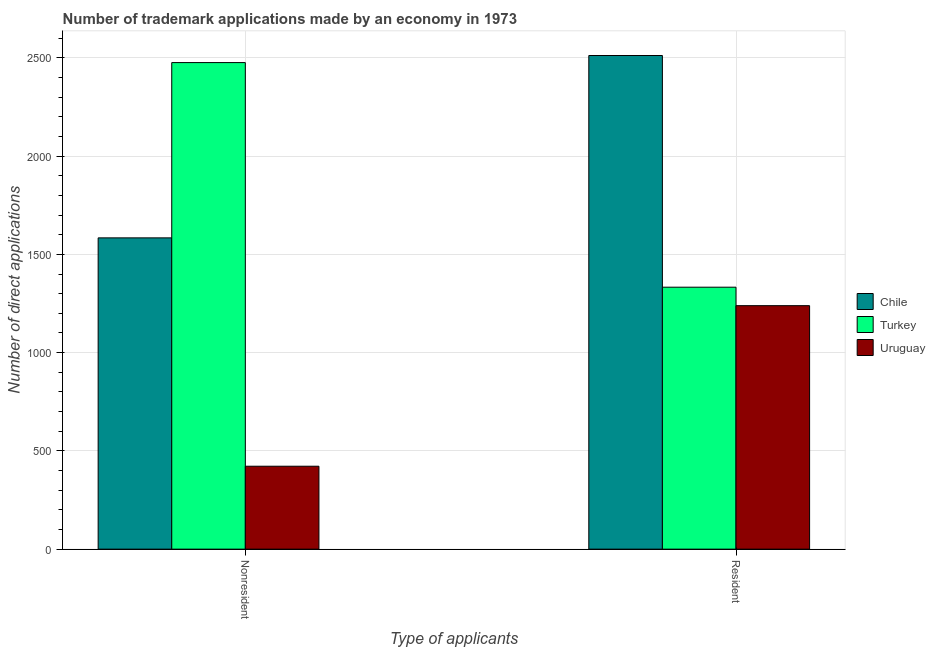How many different coloured bars are there?
Provide a short and direct response. 3. How many groups of bars are there?
Offer a very short reply. 2. Are the number of bars on each tick of the X-axis equal?
Provide a succinct answer. Yes. What is the label of the 2nd group of bars from the left?
Offer a very short reply. Resident. What is the number of trademark applications made by residents in Turkey?
Make the answer very short. 1333. Across all countries, what is the maximum number of trademark applications made by residents?
Offer a very short reply. 2512. Across all countries, what is the minimum number of trademark applications made by residents?
Give a very brief answer. 1239. In which country was the number of trademark applications made by residents maximum?
Give a very brief answer. Chile. In which country was the number of trademark applications made by residents minimum?
Your answer should be compact. Uruguay. What is the total number of trademark applications made by residents in the graph?
Make the answer very short. 5084. What is the difference between the number of trademark applications made by residents in Chile and that in Uruguay?
Your answer should be very brief. 1273. What is the difference between the number of trademark applications made by residents in Chile and the number of trademark applications made by non residents in Uruguay?
Provide a short and direct response. 2090. What is the average number of trademark applications made by residents per country?
Your response must be concise. 1694.67. What is the difference between the number of trademark applications made by non residents and number of trademark applications made by residents in Uruguay?
Your answer should be very brief. -817. In how many countries, is the number of trademark applications made by non residents greater than 900 ?
Your answer should be compact. 2. What is the ratio of the number of trademark applications made by residents in Uruguay to that in Turkey?
Make the answer very short. 0.93. In how many countries, is the number of trademark applications made by residents greater than the average number of trademark applications made by residents taken over all countries?
Provide a short and direct response. 1. What does the 3rd bar from the left in Nonresident represents?
Make the answer very short. Uruguay. What does the 3rd bar from the right in Nonresident represents?
Ensure brevity in your answer.  Chile. Are all the bars in the graph horizontal?
Offer a very short reply. No. How many countries are there in the graph?
Your answer should be compact. 3. What is the difference between two consecutive major ticks on the Y-axis?
Keep it short and to the point. 500. Where does the legend appear in the graph?
Your answer should be compact. Center right. How many legend labels are there?
Make the answer very short. 3. How are the legend labels stacked?
Ensure brevity in your answer.  Vertical. What is the title of the graph?
Give a very brief answer. Number of trademark applications made by an economy in 1973. What is the label or title of the X-axis?
Keep it short and to the point. Type of applicants. What is the label or title of the Y-axis?
Offer a terse response. Number of direct applications. What is the Number of direct applications in Chile in Nonresident?
Provide a succinct answer. 1584. What is the Number of direct applications in Turkey in Nonresident?
Your answer should be compact. 2476. What is the Number of direct applications in Uruguay in Nonresident?
Give a very brief answer. 422. What is the Number of direct applications in Chile in Resident?
Provide a short and direct response. 2512. What is the Number of direct applications of Turkey in Resident?
Provide a short and direct response. 1333. What is the Number of direct applications in Uruguay in Resident?
Offer a very short reply. 1239. Across all Type of applicants, what is the maximum Number of direct applications in Chile?
Your answer should be very brief. 2512. Across all Type of applicants, what is the maximum Number of direct applications of Turkey?
Give a very brief answer. 2476. Across all Type of applicants, what is the maximum Number of direct applications in Uruguay?
Offer a very short reply. 1239. Across all Type of applicants, what is the minimum Number of direct applications of Chile?
Give a very brief answer. 1584. Across all Type of applicants, what is the minimum Number of direct applications in Turkey?
Give a very brief answer. 1333. Across all Type of applicants, what is the minimum Number of direct applications of Uruguay?
Provide a short and direct response. 422. What is the total Number of direct applications of Chile in the graph?
Your response must be concise. 4096. What is the total Number of direct applications of Turkey in the graph?
Offer a terse response. 3809. What is the total Number of direct applications in Uruguay in the graph?
Make the answer very short. 1661. What is the difference between the Number of direct applications in Chile in Nonresident and that in Resident?
Provide a short and direct response. -928. What is the difference between the Number of direct applications of Turkey in Nonresident and that in Resident?
Offer a very short reply. 1143. What is the difference between the Number of direct applications in Uruguay in Nonresident and that in Resident?
Your response must be concise. -817. What is the difference between the Number of direct applications of Chile in Nonresident and the Number of direct applications of Turkey in Resident?
Offer a very short reply. 251. What is the difference between the Number of direct applications of Chile in Nonresident and the Number of direct applications of Uruguay in Resident?
Your response must be concise. 345. What is the difference between the Number of direct applications in Turkey in Nonresident and the Number of direct applications in Uruguay in Resident?
Provide a succinct answer. 1237. What is the average Number of direct applications of Chile per Type of applicants?
Provide a succinct answer. 2048. What is the average Number of direct applications in Turkey per Type of applicants?
Your response must be concise. 1904.5. What is the average Number of direct applications of Uruguay per Type of applicants?
Keep it short and to the point. 830.5. What is the difference between the Number of direct applications in Chile and Number of direct applications in Turkey in Nonresident?
Your answer should be very brief. -892. What is the difference between the Number of direct applications in Chile and Number of direct applications in Uruguay in Nonresident?
Your answer should be compact. 1162. What is the difference between the Number of direct applications of Turkey and Number of direct applications of Uruguay in Nonresident?
Offer a very short reply. 2054. What is the difference between the Number of direct applications in Chile and Number of direct applications in Turkey in Resident?
Your answer should be very brief. 1179. What is the difference between the Number of direct applications of Chile and Number of direct applications of Uruguay in Resident?
Give a very brief answer. 1273. What is the difference between the Number of direct applications of Turkey and Number of direct applications of Uruguay in Resident?
Offer a terse response. 94. What is the ratio of the Number of direct applications of Chile in Nonresident to that in Resident?
Your response must be concise. 0.63. What is the ratio of the Number of direct applications in Turkey in Nonresident to that in Resident?
Your answer should be compact. 1.86. What is the ratio of the Number of direct applications in Uruguay in Nonresident to that in Resident?
Give a very brief answer. 0.34. What is the difference between the highest and the second highest Number of direct applications of Chile?
Make the answer very short. 928. What is the difference between the highest and the second highest Number of direct applications of Turkey?
Ensure brevity in your answer.  1143. What is the difference between the highest and the second highest Number of direct applications in Uruguay?
Offer a terse response. 817. What is the difference between the highest and the lowest Number of direct applications in Chile?
Give a very brief answer. 928. What is the difference between the highest and the lowest Number of direct applications of Turkey?
Your response must be concise. 1143. What is the difference between the highest and the lowest Number of direct applications in Uruguay?
Offer a terse response. 817. 